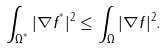<formula> <loc_0><loc_0><loc_500><loc_500>\int _ { \Omega ^ { ^ { * } } } | \nabla f ^ { ^ { * } } | ^ { 2 } \leq \int _ { \Omega } | \nabla f | ^ { 2 } .</formula> 